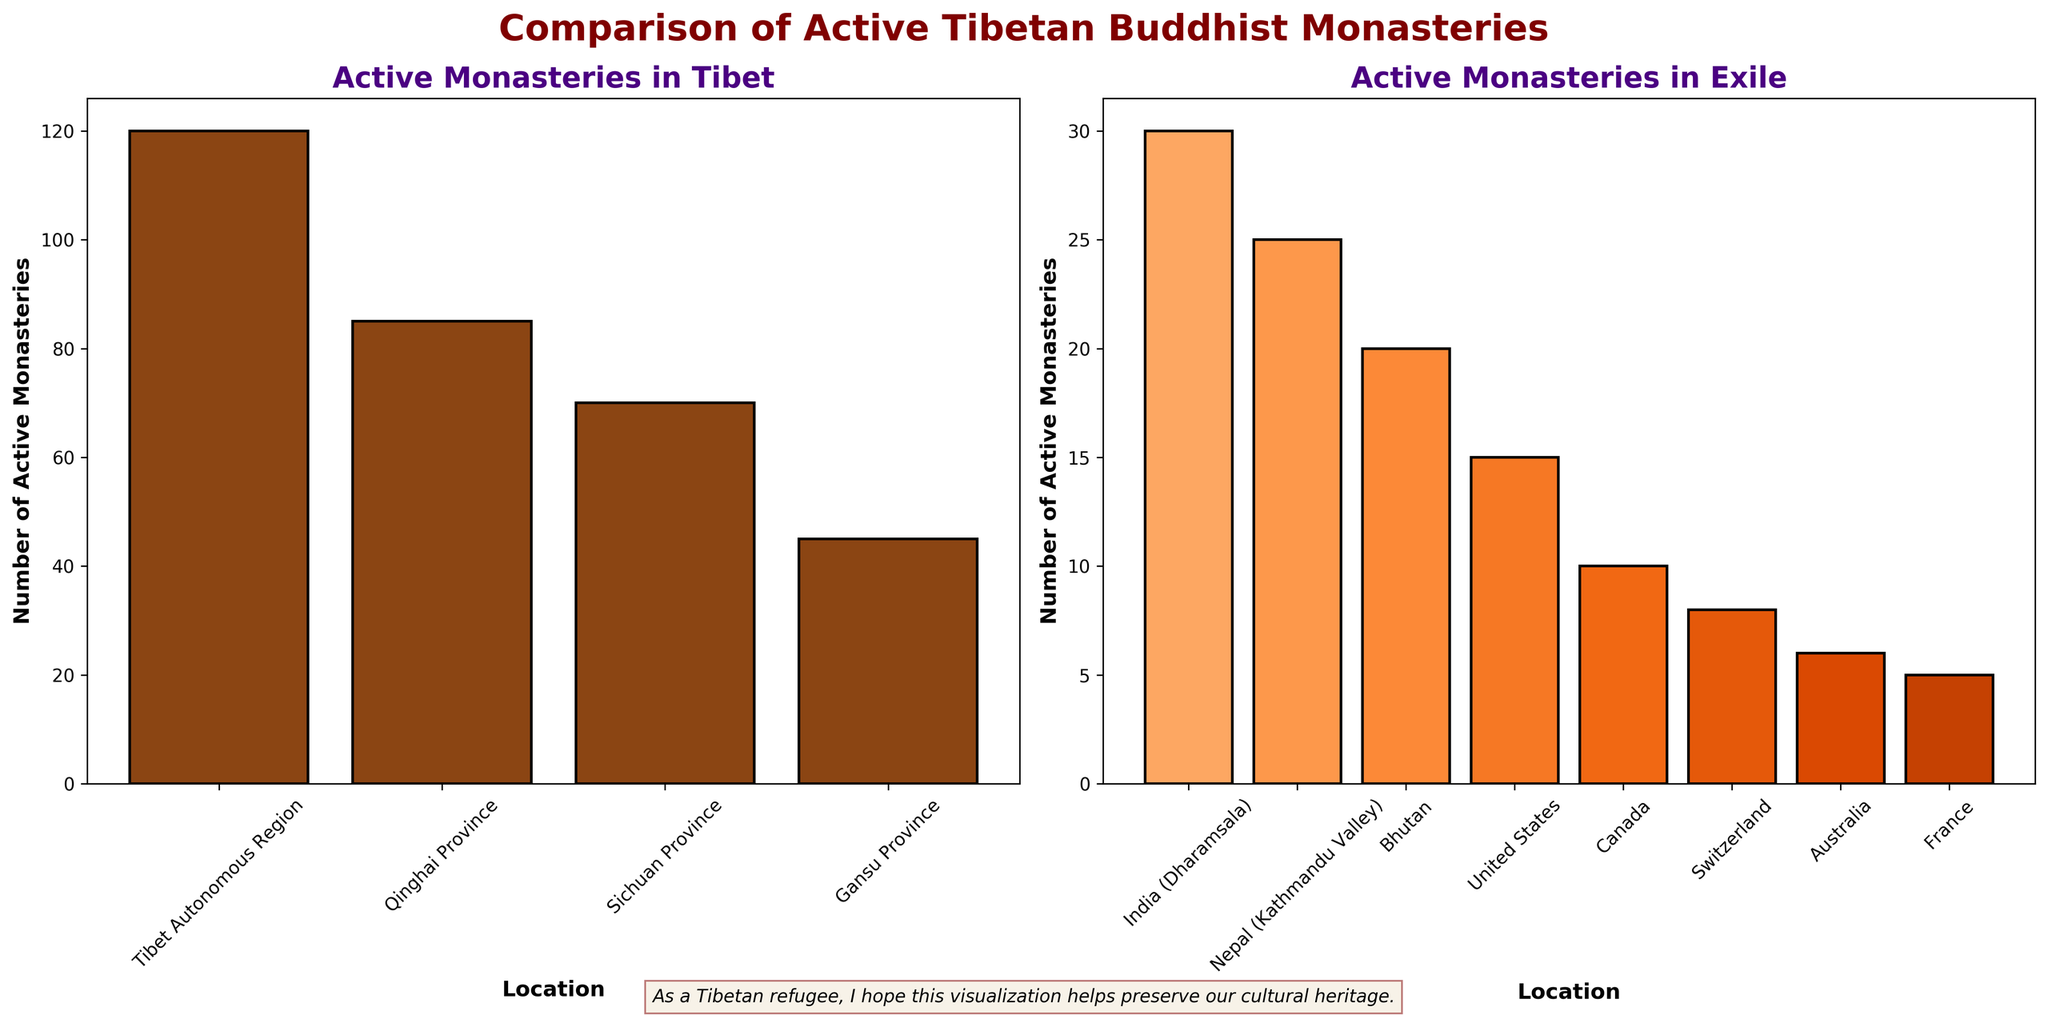How many more active monasteries are there in the Tibet Autonomous Region compared to India (Dharamsala)? The Tibet Autonomous Region has 120 active monasteries, and India (Dharamsala) has 30. The difference is found by subtracting the number in India from the number in Tibet Autonomous Region: 120 - 30 = 90.
Answer: 90 Which location in exile has the highest number of active monasteries? To find the location in exile with the highest number of active monasteries, look at the "Number of Active Monasteries" bar heights for the exile locations. India (Dharamsala) has the highest number with 30 active monasteries.
Answer: India (Dharamsala) What is the total number of active monasteries in all locations outside of Tibet? Sum the number of active monasteries in all exile locations: 30 (India) + 25 (Nepal) + 20 (Bhutan) + 15 (United States) + 10 (Canada) + 8 (Switzerland) + 6 (Australia) + 5 (France) = 119.
Answer: 119 Are there more active monasteries in the Tibet Autonomous Region or all exile locations combined? The Tibet Autonomous Region has 120 active monasteries. The total number in exile is 119. Since 120 is greater than 119, there are more active monasteries in the Tibet Autonomous Region.
Answer: Tibet Autonomous Region Which province within Tibet has the least number of active monasteries, and how many are there? Compare the number of active monasteries in each province within Tibet. Gansu Province has the least number of active monasteries with 45.
Answer: Gansu Province, 45 What is the combined number of active monasteries in Sichuan and Qinghai compared to Nepal and Bhutan? Sichuan has 70 and Qinghai has 85 active monasteries, so their combined number is 70 + 85 = 155. Nepal has 25 and Bhutan has 20, so their combined number is 25 + 20 = 45. Compare the totals: 155 (Sichuan and Qinghai) vs. 45 (Nepal and Bhutan).
Answer: 155 vs. 45 What is the average number of active monasteries in locations outside of Tibet with fewer than 10 monasteries? Only Canada, Switzerland, Australia, and France have fewer than 10 monasteries. Their numbers are 10, 8, 6, and 5 respectively. The average is calculated as (10 + 8 + 6 + 5) / 4 = 29 / 4 = 7.25.
Answer: 7.25 Which color corresponds to the bars representing exile locations? The bars representing exile locations are shaded in varying tones of orange.
Answer: Orange 